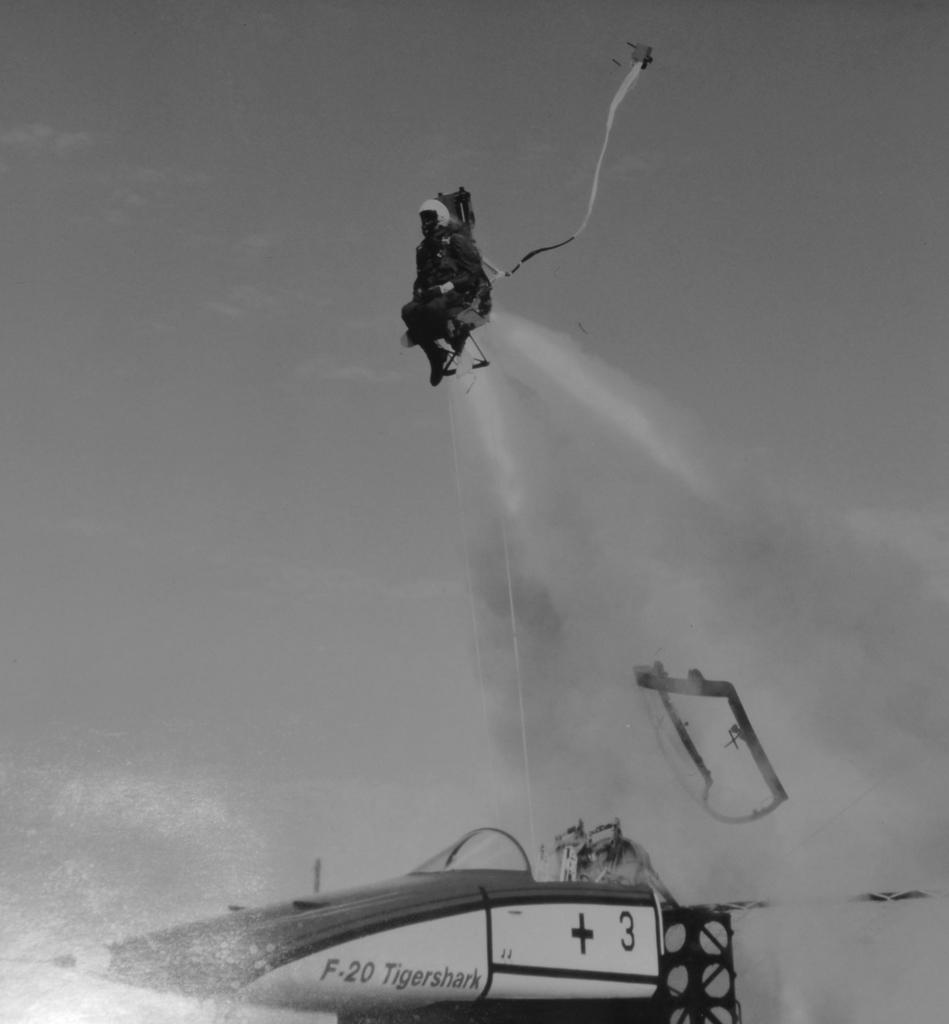What is the main subject of the image? The main subject of the image is a jet plane. What is happening to the person in the image? A person is ejected from the jet plane in the image. How is the person positioned in the image? The person is in the air with their seat. What can be seen in the sky in the image? There are clouds visible in the sky. What type of bulb is illuminating the girls playing in the square in the image? There are no girls playing in a square or any bulbs present in the image; it features a jet plane and a person being ejected from it. 